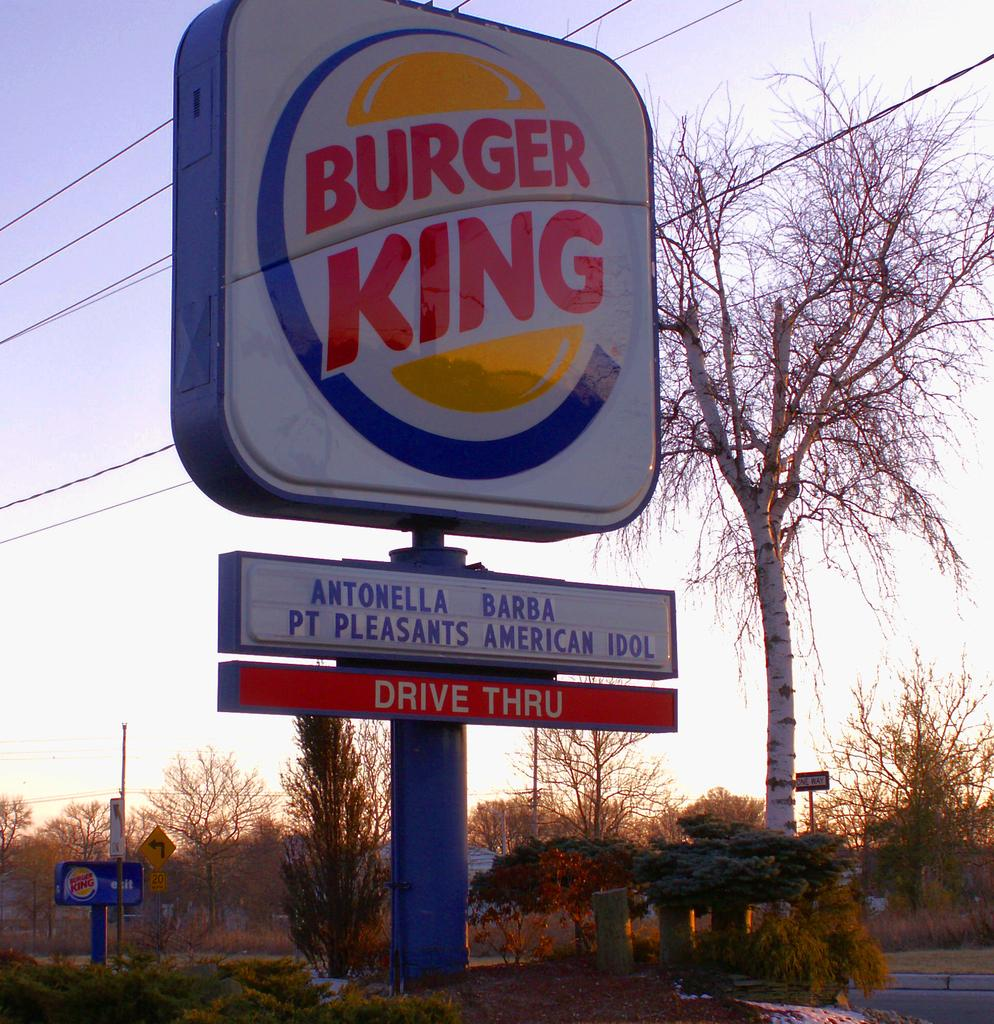<image>
Render a clear and concise summary of the photo. Burger King sign advertising ANTONELLA BARBA PT PLEASANTS AMERICAN IDOL. 